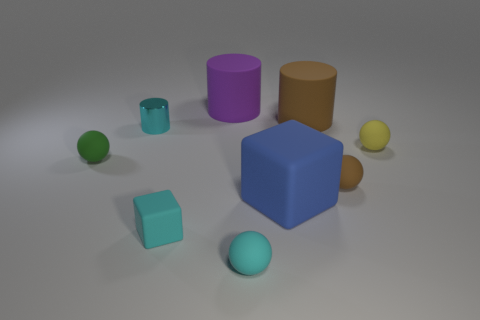Add 1 small cyan rubber cubes. How many objects exist? 10 Subtract all cubes. How many objects are left? 7 Add 8 purple matte objects. How many purple matte objects are left? 9 Add 5 yellow matte objects. How many yellow matte objects exist? 6 Subtract 0 green cylinders. How many objects are left? 9 Subtract all large purple rubber objects. Subtract all small metallic things. How many objects are left? 7 